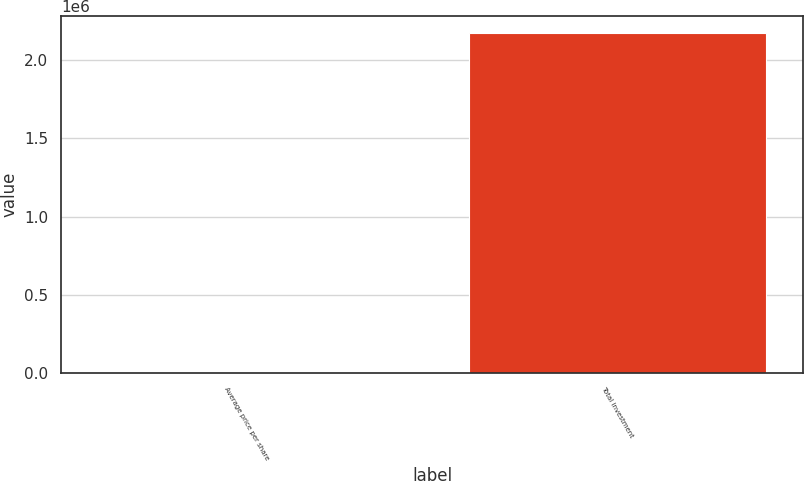Convert chart. <chart><loc_0><loc_0><loc_500><loc_500><bar_chart><fcel>Average price per share<fcel>Total investment<nl><fcel>233.57<fcel>2.17244e+06<nl></chart> 